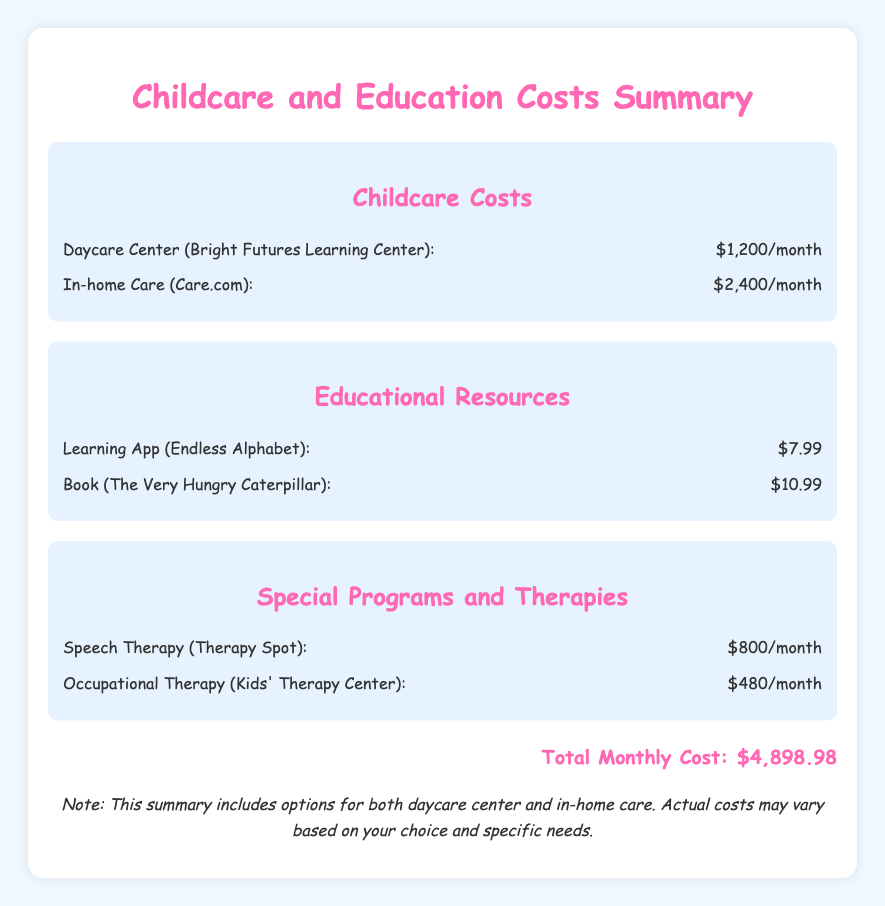What is the monthly cost for the daycare center? The document states that the monthly cost for the daycare center (Bright Futures Learning Center) is $1,200.
Answer: $1,200 How much does in-home care cost monthly? The cost for in-home care (Care.com) is listed in the document as $2,400 per month.
Answer: $2,400 What is the cost of the speech therapy? The document indicates that speech therapy (Therapy Spot) costs $800 per month.
Answer: $800 What is the total monthly cost of all childcare and education expenses? The document totals all costs for childcare, educational resources, and therapies to be $4,898.98.
Answer: $4,898.98 What is the price of the book "The Very Hungry Caterpillar"? According to the document, the price of the book is $10.99.
Answer: $10.99 Which learning app is mentioned and how much does it cost? The document lists the learning app as "Endless Alphabet" and its cost is $7.99.
Answer: $7.99 Which therapy is less expensive: speech therapy or occupational therapy? The document shows that occupational therapy (Kids' Therapy Center) costs $480, which is less than speech therapy at $800.
Answer: Occupational Therapy How many types of costs are summarized in the document? The document summarizes three main types of costs: childcare costs, educational resources, and special programs/therapies.
Answer: Three What is the note in the document about costs? The note in the document mentions that the summary includes options for both daycare center and in-home care, indicating potential variability in actual costs.
Answer: Options for both daycare center and in-home care 